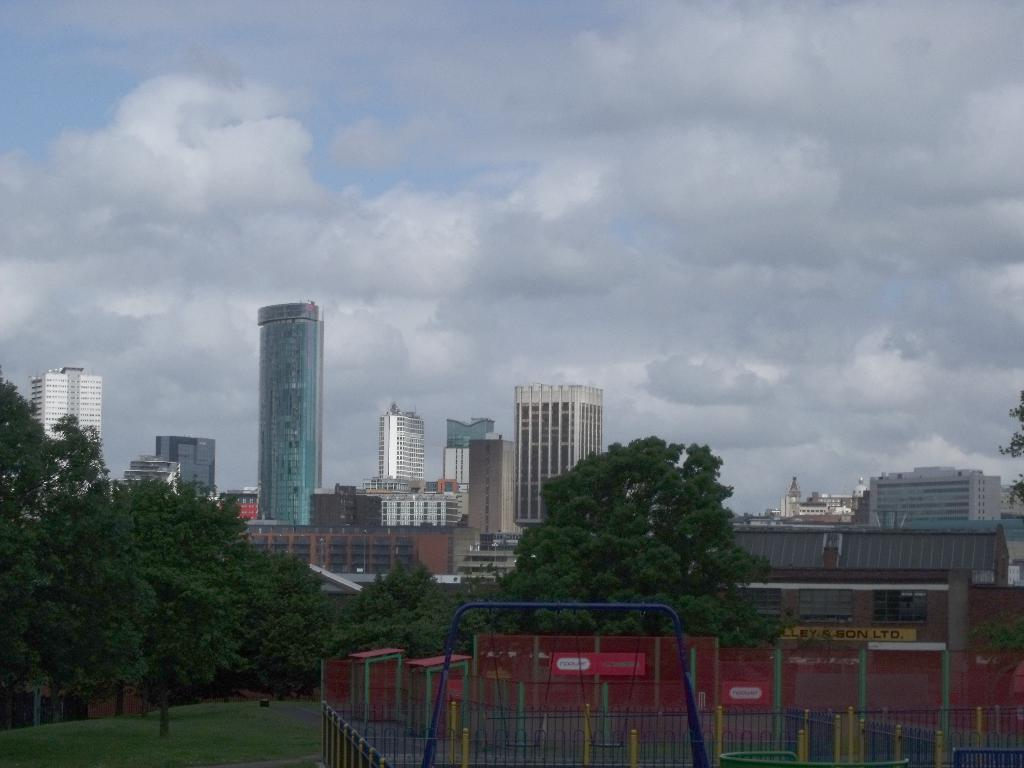What type of structures can be seen in the image? There are buildings in the image. What type of vegetation is present in the image? There are trees in the image. What is at the bottom of the image? There is grass at the bottom of the image. What type of playground equipment can be seen in the image? There are slides in the image. What type of barrier is present in the image? There is fencing in the image. What is visible at the top of the image? There is sky visible at the top of the image. Can you describe the weather in the image? There is at least one cloud in the sky, suggesting that it might be partly cloudy. How many quinces are hanging from the trees in the image? There are no quinces present in the image; it features trees, buildings, slides, and fencing. What type of shade is provided by the buildings in the image? There is no mention of shade in the image, as it focuses on the structures, vegetation, and playground equipment. 